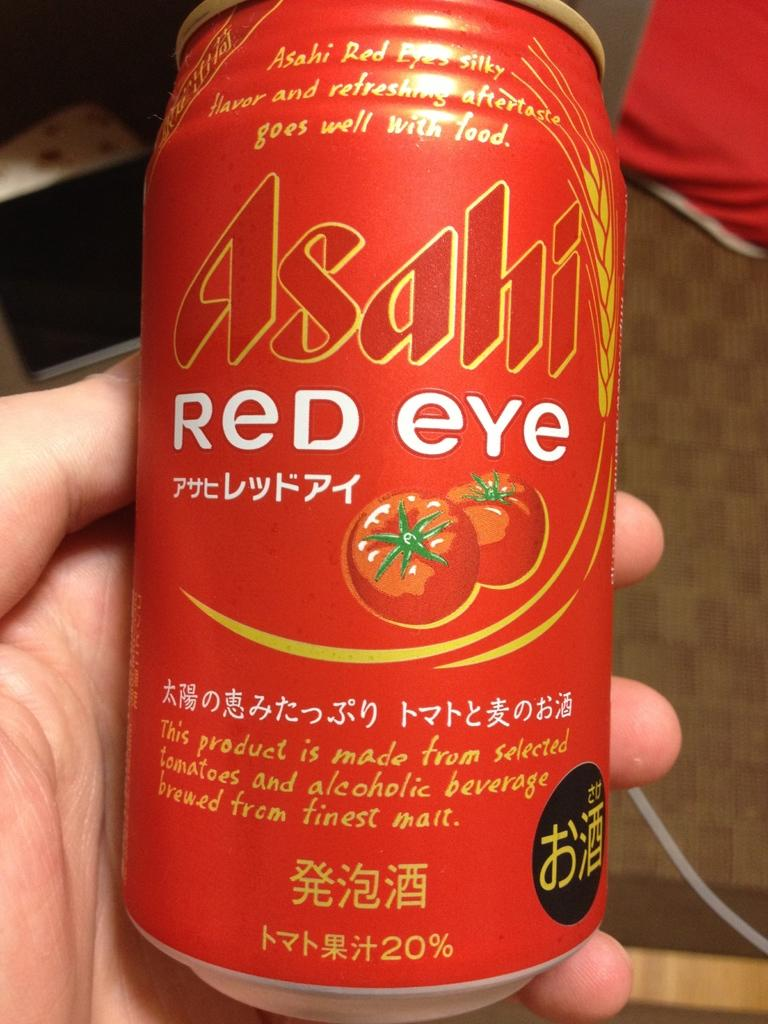<image>
Summarize the visual content of the image. Asashi Red Eye Tomato type juice can that says it goes well with food and has a refreshing aftertaste. 